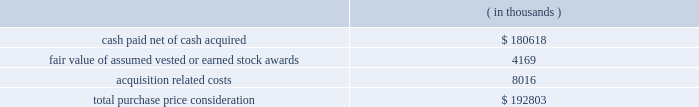Synopsys , inc .
Notes to consolidated financial statements 2014 ( continued ) and other electronic applications markets .
The company believes the acquisition will expand its technology portfolio , channel reach and total addressable market by adding complementary products and expertise for fpga solutions and rapid asic prototyping .
Purchase price .
Synopsys paid $ 8.00 per share for all outstanding shares including certain vested options of synplicity for an aggregate cash payment of $ 223.3 million .
Additionally , synopsys assumed certain employee stock options and restricted stock units , collectively called 201cstock awards . 201d the total purchase consideration consisted of: .
Acquisition related costs consist primarily of professional services , severance and employee related costs and facilities closure costs of which $ 6.8 million have been paid as of october 31 , 2009 .
Fair value of stock awards assumed .
An aggregate of 4.7 million shares of synplicity stock options and restricted stock units were exchanged for synopsys stock options and restricted stock units at an exchange ratio of 0.3392 per share .
The fair value of stock options assumed was determined using a black-scholes valuation model .
The fair value of stock awards vested or earned of $ 4.2 million was included as part of the purchase price .
The fair value of unvested awards of $ 5.0 million will be recorded as operating expense over the remaining service periods on a straight-line basis .
Purchase price allocation .
The company allocated $ 80.0 million of the purchase price to identifiable intangible assets to be amortized over two to seven years .
In-process research and development expense related to these acquisitions was $ 4.8 million .
Goodwill , representing the excess of the purchase price over the fair value of tangible and identifiable intangible assets acquired , was $ 120.3 million and will not be amortized .
Goodwill primarily resulted from the company 2019s expectation of cost synergies and sales growth from the integration of synplicity 2019s technology with the company 2019s technology and operations to provide an expansion of products and market reach .
Fiscal 2007 acquisitions during fiscal year 2007 , the company completed certain purchase acquisitions for cash .
The company allocated the total purchase considerations of $ 54.8 million ( which included acquisition related costs of $ 1.4 million ) to the assets and liabilities acquired , including identifiable intangible assets , based on their respective fair values at the acquisition dates , resulting in aggregate goodwill of $ 36.6 million .
Acquired identifiable intangible assets of $ 14.3 million are being amortized over two to nine years .
In-process research and development expense related to these acquisitions was $ 3.2 million. .
What percentage of total purchase price consideration was allocated to identifiable intangible assets? 
Computations: ((80.0 * 1000) / 192803)
Answer: 0.41493. 